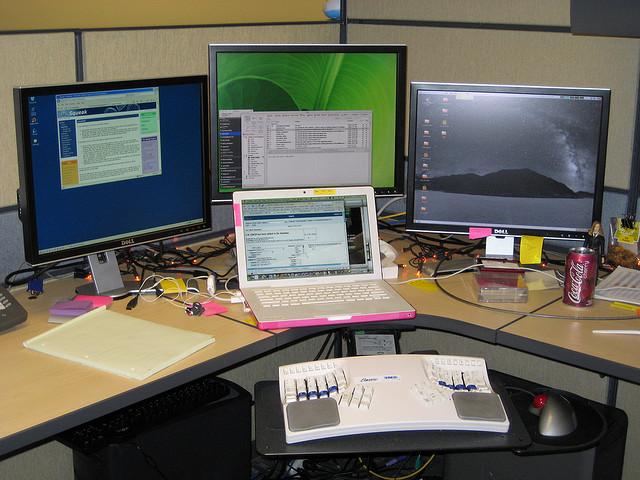How many screens do you see?
Give a very brief answer. 4. What brand of laptop is on the desk?
Write a very short answer. Dell. Is the can of soda open?
Short answer required. Yes. What company made the monitors?
Give a very brief answer. Dell. Are the screens on?
Write a very short answer. Yes. How many computers?
Quick response, please. 4. Is this a desktop computer?
Concise answer only. Yes. What toy is on top of the speaker?
Keep it brief. None. 